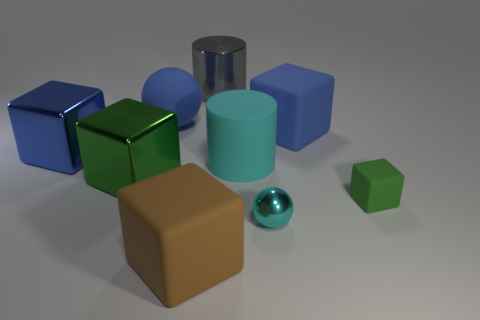Subtract all big blue metal blocks. How many blocks are left? 4 Subtract all brown blocks. How many blocks are left? 4 Subtract all purple cubes. Subtract all purple spheres. How many cubes are left? 5 Subtract all spheres. How many objects are left? 7 Add 9 rubber spheres. How many rubber spheres exist? 10 Subtract 0 gray blocks. How many objects are left? 9 Subtract all big rubber objects. Subtract all large brown things. How many objects are left? 4 Add 5 tiny matte cubes. How many tiny matte cubes are left? 6 